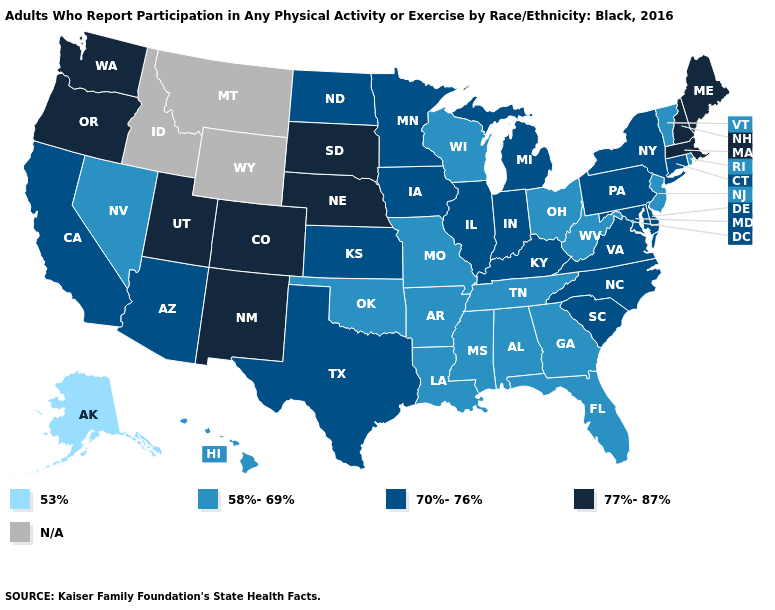Name the states that have a value in the range 77%-87%?
Short answer required. Colorado, Maine, Massachusetts, Nebraska, New Hampshire, New Mexico, Oregon, South Dakota, Utah, Washington. Among the states that border Rhode Island , does Connecticut have the lowest value?
Write a very short answer. Yes. Does North Carolina have the lowest value in the South?
Be succinct. No. Name the states that have a value in the range 53%?
Quick response, please. Alaska. What is the value of Illinois?
Keep it brief. 70%-76%. How many symbols are there in the legend?
Answer briefly. 5. Which states have the lowest value in the USA?
Keep it brief. Alaska. What is the highest value in the USA?
Be succinct. 77%-87%. What is the value of Pennsylvania?
Give a very brief answer. 70%-76%. What is the value of Texas?
Concise answer only. 70%-76%. Is the legend a continuous bar?
Concise answer only. No. Does Alaska have the lowest value in the USA?
Answer briefly. Yes. Does Indiana have the lowest value in the USA?
Concise answer only. No. 